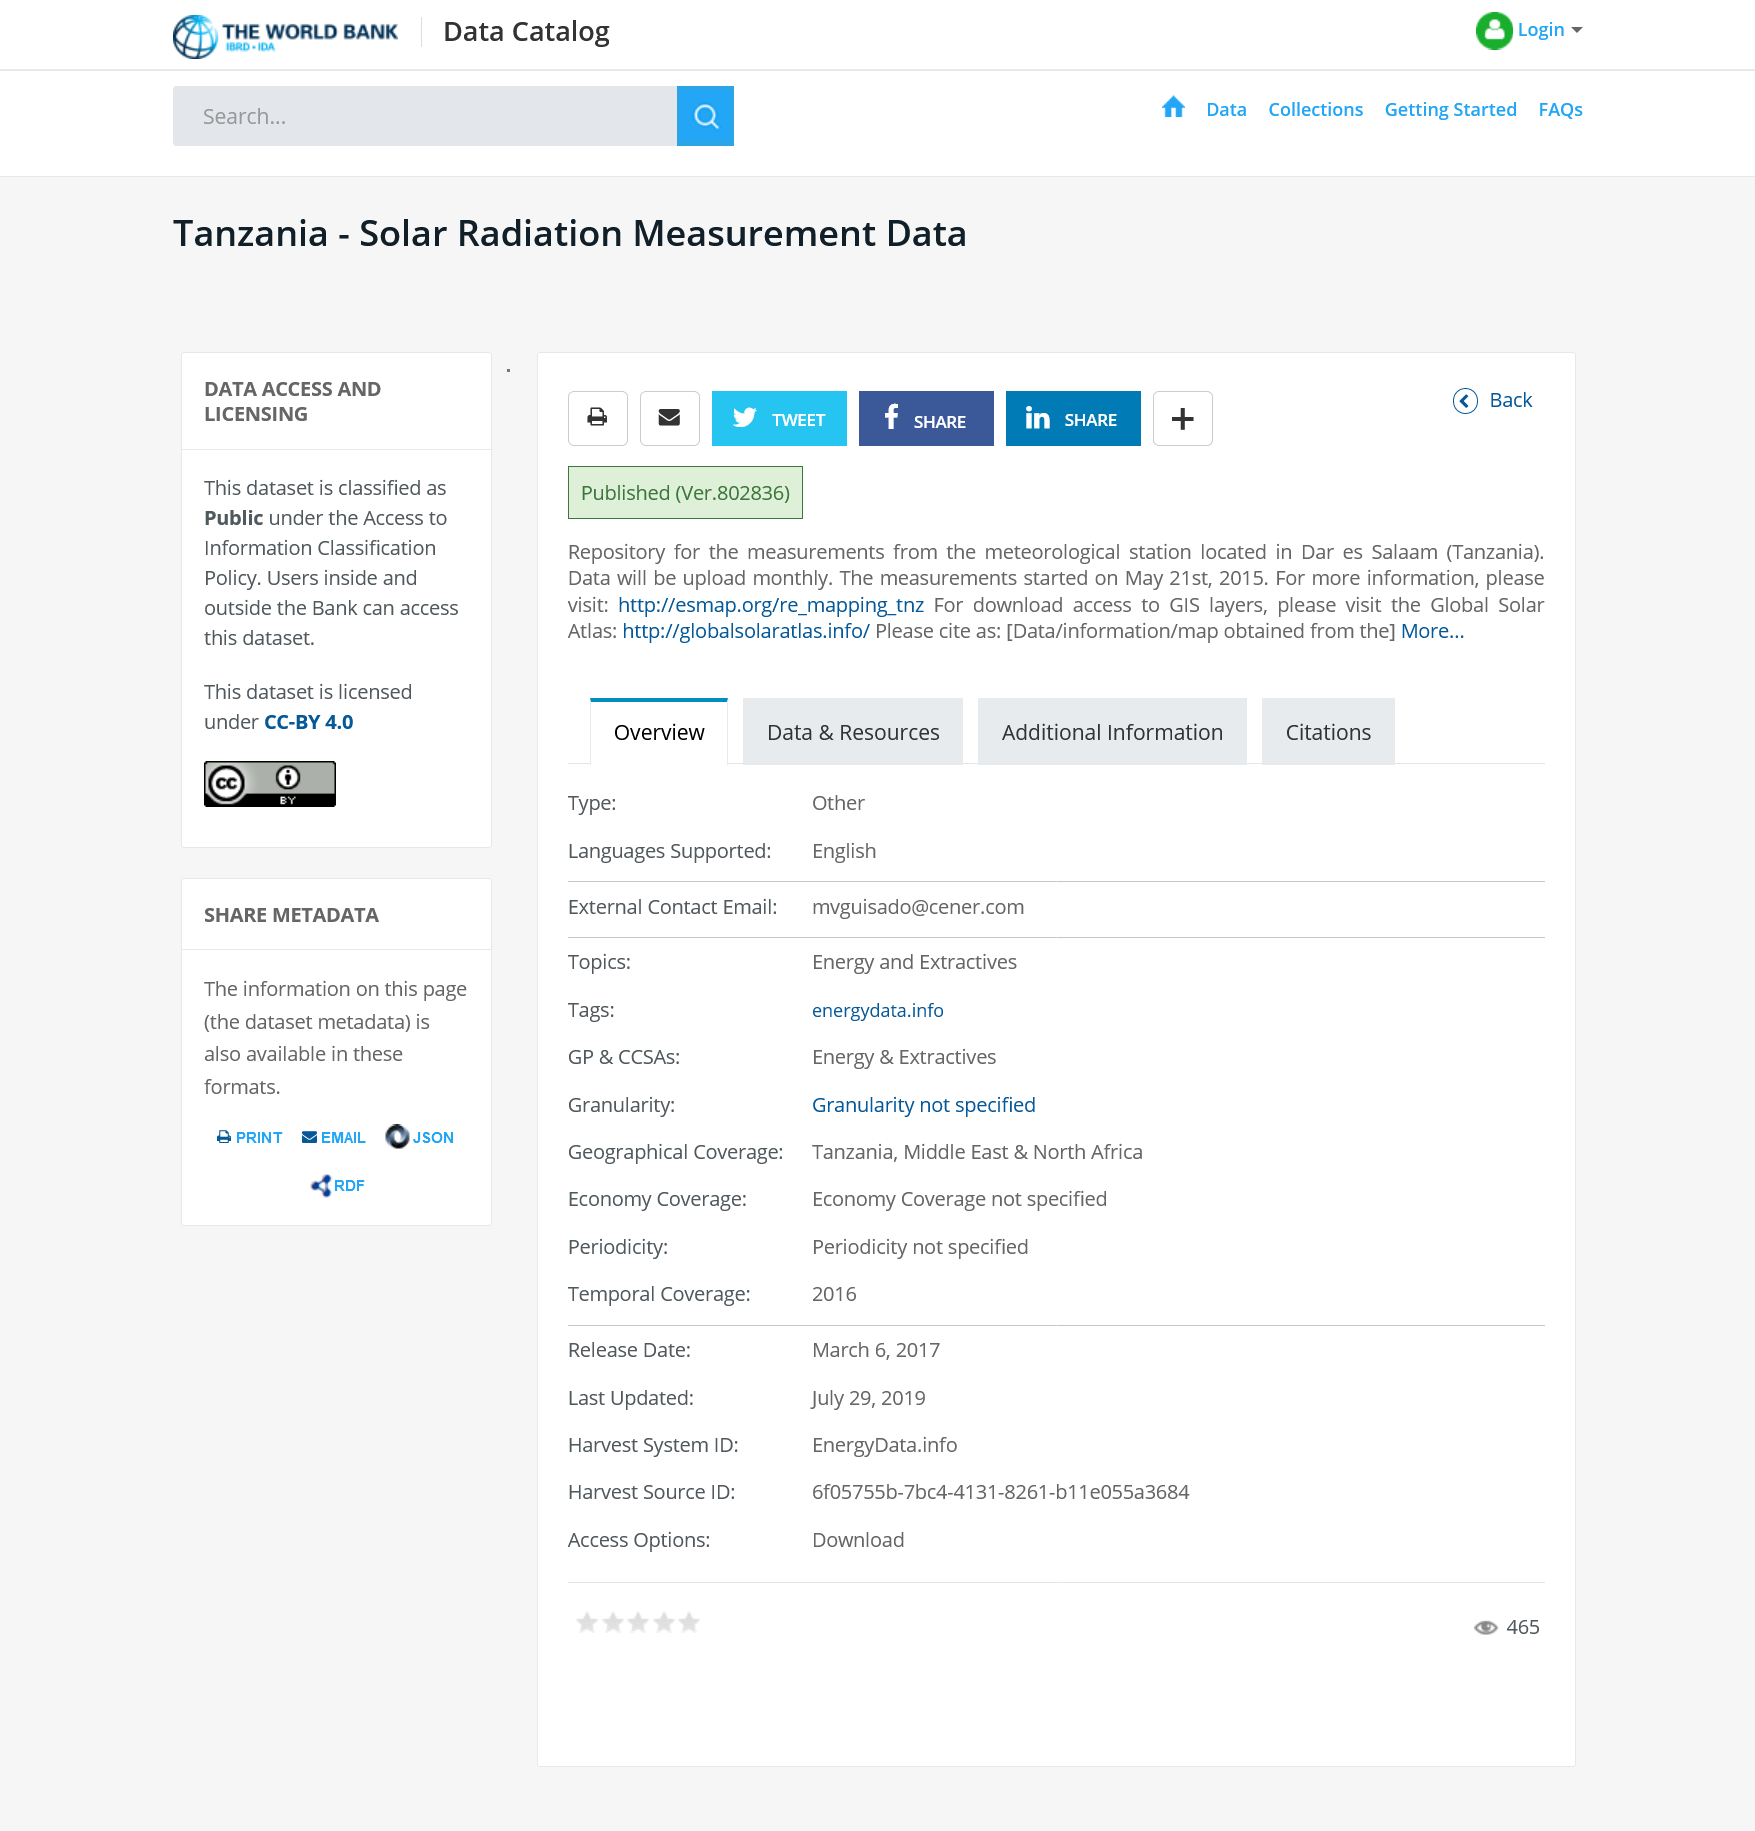Identify some key points in this picture. The article provides information on solar radiation measurement data obtained from Tanzania. The Access to Information Classification Policy classifies this dataset as "Public", which means it is freely available for anyone to access. 